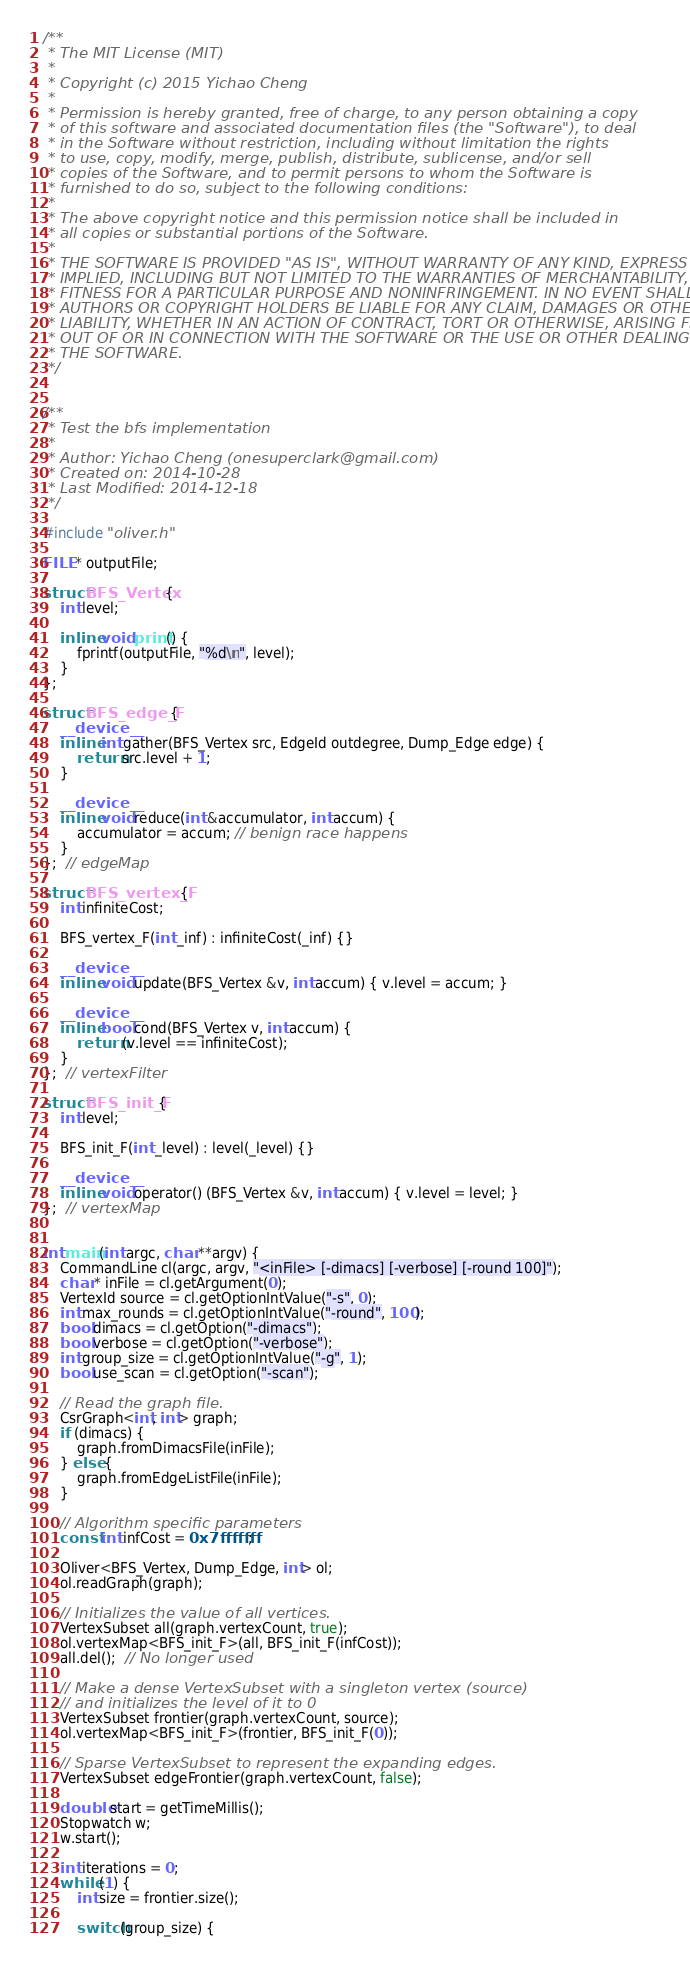<code> <loc_0><loc_0><loc_500><loc_500><_Cuda_>/**
 * The MIT License (MIT)
 *
 * Copyright (c) 2015 Yichao Cheng
 * 
 * Permission is hereby granted, free of charge, to any person obtaining a copy
 * of this software and associated documentation files (the "Software"), to deal
 * in the Software without restriction, including without limitation the rights
 * to use, copy, modify, merge, publish, distribute, sublicense, and/or sell
 * copies of the Software, and to permit persons to whom the Software is
 * furnished to do so, subject to the following conditions:
 * 
 * The above copyright notice and this permission notice shall be included in
 * all copies or substantial portions of the Software.
 * 
 * THE SOFTWARE IS PROVIDED "AS IS", WITHOUT WARRANTY OF ANY KIND, EXPRESS OR
 * IMPLIED, INCLUDING BUT NOT LIMITED TO THE WARRANTIES OF MERCHANTABILITY,
 * FITNESS FOR A PARTICULAR PURPOSE AND NONINFRINGEMENT. IN NO EVENT SHALL THE
 * AUTHORS OR COPYRIGHT HOLDERS BE LIABLE FOR ANY CLAIM, DAMAGES OR OTHER
 * LIABILITY, WHETHER IN AN ACTION OF CONTRACT, TORT OR OTHERWISE, ARISING FROM,
 * OUT OF OR IN CONNECTION WITH THE SOFTWARE OR THE USE OR OTHER DEALINGS IN
 * THE SOFTWARE.
 */


/**
 * Test the bfs implementation
 *
 * Author: Yichao Cheng (onesuperclark@gmail.com)
 * Created on: 2014-10-28
 * Last Modified: 2014-12-18
 */

#include "oliver.h"

FILE * outputFile;

struct BFS_Vertex {
    int level;

    inline void print() {
        fprintf(outputFile, "%d\n", level);
    }
};

struct BFS_edge_F {
    __device__
    inline int gather(BFS_Vertex src, EdgeId outdegree, Dump_Edge edge) {
        return src.level + 1;        
    }

    __device__
    inline void reduce(int &accumulator, int accum) {
        accumulator = accum; // benign race happens
    }
};  // edgeMap

struct BFS_vertex_F {
    int infiniteCost;

    BFS_vertex_F(int _inf) : infiniteCost(_inf) {}

    __device__
    inline void update(BFS_Vertex &v, int accum) { v.level = accum; }

    __device__
    inline bool cond(BFS_Vertex v, int accum) {
        return (v.level == infiniteCost);
    }
};  // vertexFilter

struct BFS_init_F {
    int level;

    BFS_init_F(int _level) : level(_level) {}

    __device__
    inline void operator() (BFS_Vertex &v, int accum) { v.level = level; }
};  // vertexMap


int main(int argc, char **argv) {
    CommandLine cl(argc, argv, "<inFile> [-dimacs] [-verbose] [-round 100]");
    char * inFile = cl.getArgument(0);
    VertexId source = cl.getOptionIntValue("-s", 0);
    int max_rounds = cl.getOptionIntValue("-round", 100);
    bool dimacs = cl.getOption("-dimacs");
    bool verbose = cl.getOption("-verbose");
    int group_size = cl.getOptionIntValue("-g", 1);
    bool use_scan = cl.getOption("-scan");

    // Read the graph file.
    CsrGraph<int, int> graph;
    if (dimacs) {
        graph.fromDimacsFile(inFile);
    } else {
        graph.fromEdgeListFile(inFile);
    }

    // Algorithm specific parameters
    const int infCost = 0x7fffffff;

    Oliver<BFS_Vertex, Dump_Edge, int> ol;
    ol.readGraph(graph);

    // Initializes the value of all vertices.
    VertexSubset all(graph.vertexCount, true);
    ol.vertexMap<BFS_init_F>(all, BFS_init_F(infCost));
    all.del();  // No longer used

    // Make a dense VertexSubset with a singleton vertex (source)
    // and initializes the level of it to 0
    VertexSubset frontier(graph.vertexCount, source);
    ol.vertexMap<BFS_init_F>(frontier, BFS_init_F(0));

    // Sparse VertexSubset to represent the expanding edges.
    VertexSubset edgeFrontier(graph.vertexCount, false); 

    double start = getTimeMillis();    
    Stopwatch w;
    w.start();

    int iterations = 0;
    while (1) {
        int size = frontier.size();
        
        switch(group_size) {</code> 